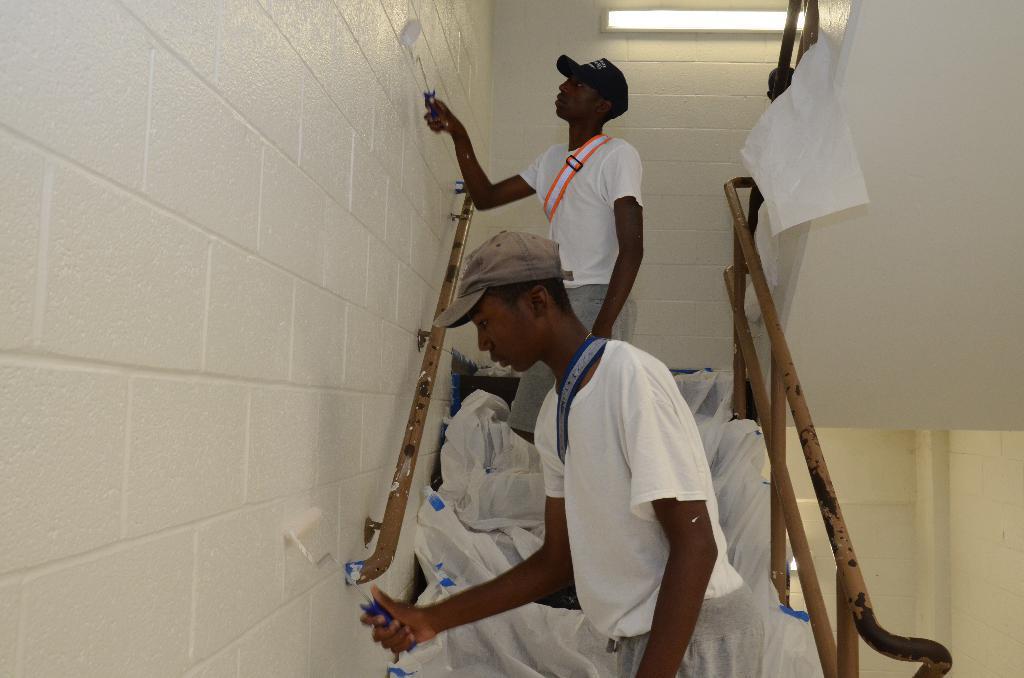Please provide a concise description of this image. In the picture I can see two men are standing on steps and holding objects in hands. I can also see stairs, a wall and some other objects. 